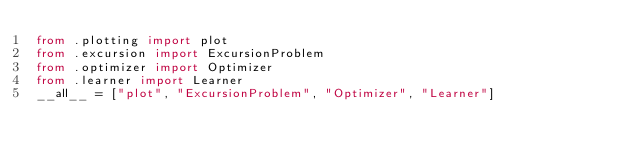Convert code to text. <code><loc_0><loc_0><loc_500><loc_500><_Python_>from .plotting import plot
from .excursion import ExcursionProblem
from .optimizer import Optimizer
from .learner import Learner
__all__ = ["plot", "ExcursionProblem", "Optimizer", "Learner"]</code> 